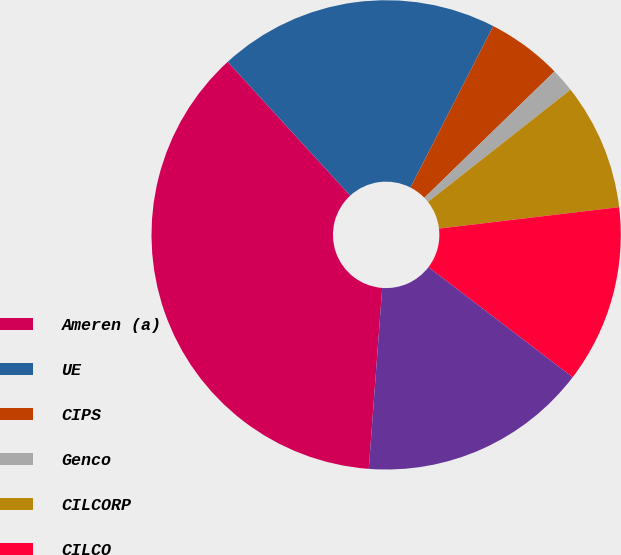Convert chart. <chart><loc_0><loc_0><loc_500><loc_500><pie_chart><fcel>Ameren (a)<fcel>UE<fcel>CIPS<fcel>Genco<fcel>CILCORP<fcel>CILCO<fcel>IP<nl><fcel>37.02%<fcel>19.34%<fcel>5.19%<fcel>1.65%<fcel>8.73%<fcel>12.26%<fcel>15.8%<nl></chart> 